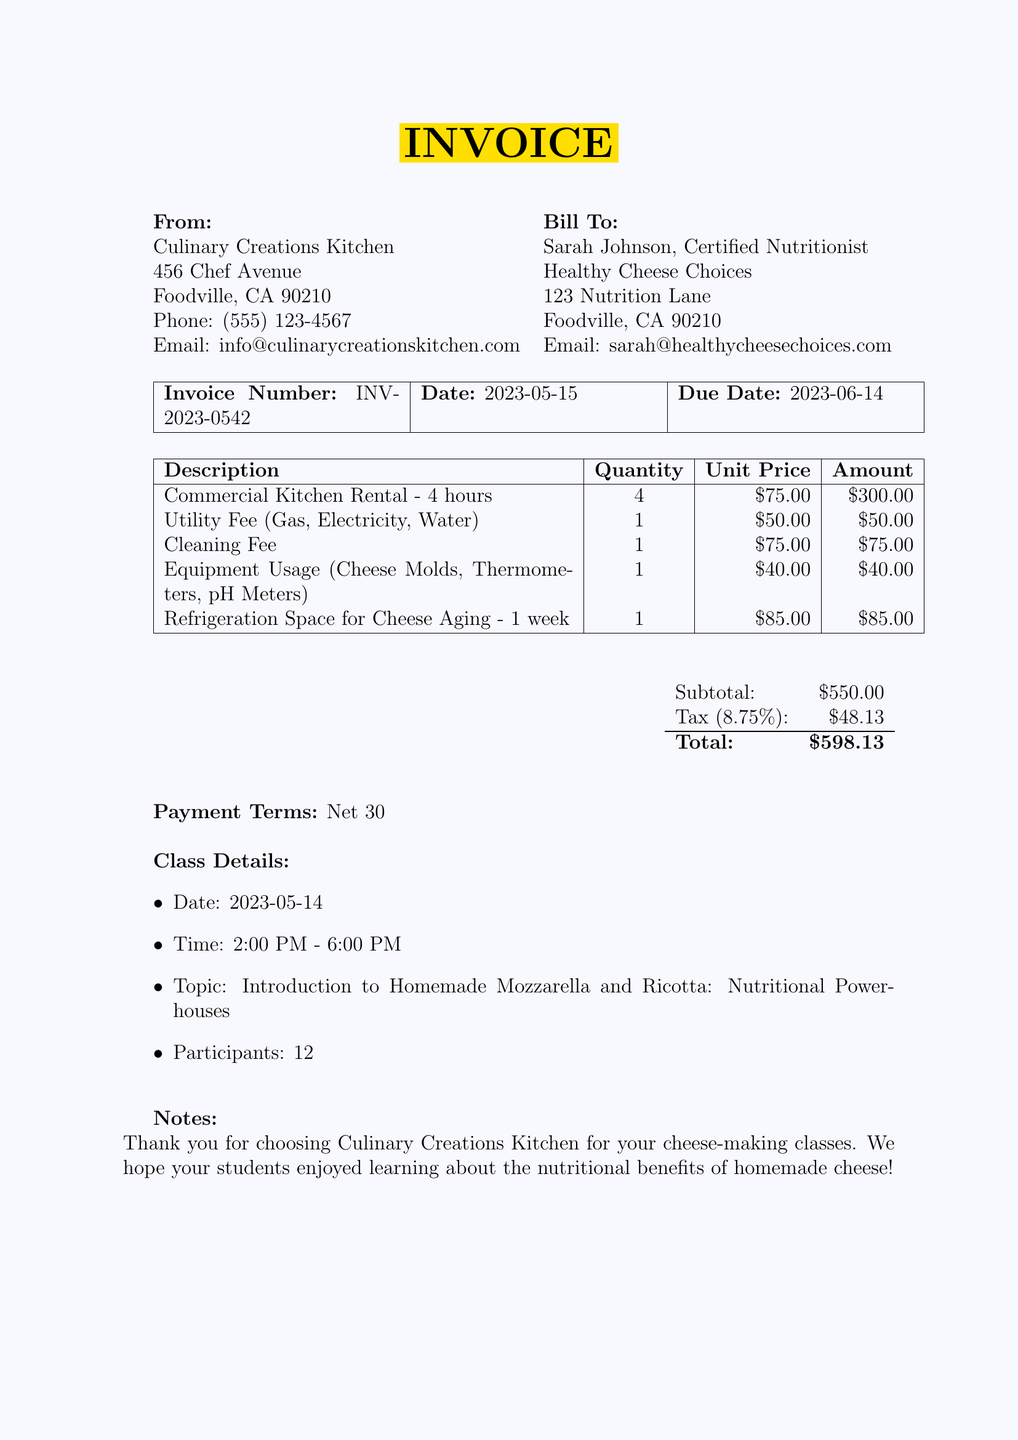What is the invoice number? The invoice number is explicitly stated at the top of the document under "Invoice Number."
Answer: INV-2023-0542 What is the due date for the invoice? The due date is listed under the same section as the invoice number.
Answer: 2023-06-14 Who is the bill to? The "Bill To" section provides the name of the individual or entity being billed.
Answer: Sarah Johnson, Certified Nutritionist What is the quantity of the commercial kitchen rental? The quantity refers to how many hours the commercial kitchen was rented.
Answer: 4 What is the total amount due? The total amount is calculated after adding all fees, taxes, and is mentioned at the end of the document.
Answer: $598.13 How many participants were in the cheese-making class? The number of participants is explicitly mentioned in the class details section at the bottom of the invoice.
Answer: 12 What are the cleaning fees? The cleaning fee is listed among the line items detailing costs associated with the invoice.
Answer: $75.00 What payment terms are specified? Payment terms outline when payment is expected and are stated near the total section.
Answer: Net 30 What is the unit price for refrigeration space for cheese aging? This information is included in the detailed line items of the invoice.
Answer: $85.00 What was the topic of the cheese-making class? The topic is clearly stated in the class details section, describing what the class was about.
Answer: Introduction to Homemade Mozzarella and Ricotta: Nutritional Powerhouses 